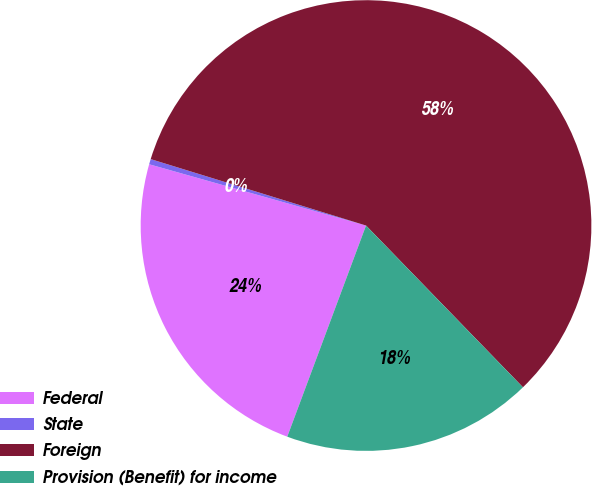Convert chart to OTSL. <chart><loc_0><loc_0><loc_500><loc_500><pie_chart><fcel>Federal<fcel>State<fcel>Foreign<fcel>Provision (Benefit) for income<nl><fcel>23.7%<fcel>0.38%<fcel>57.98%<fcel>17.94%<nl></chart> 